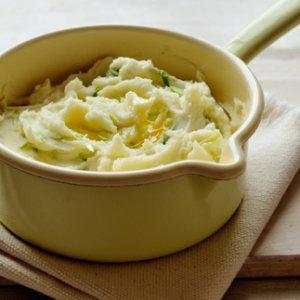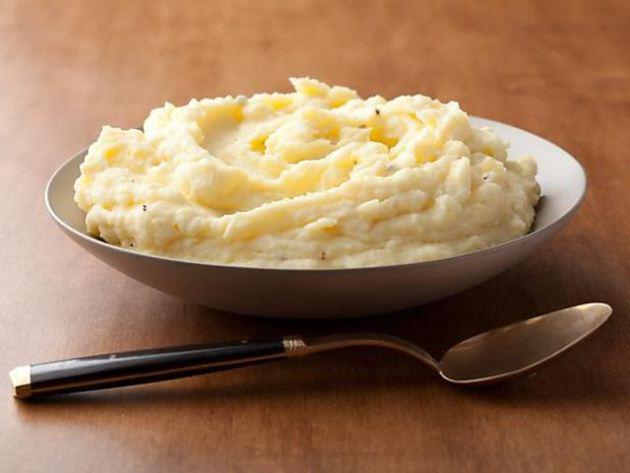The first image is the image on the left, the second image is the image on the right. Evaluate the accuracy of this statement regarding the images: "The right hand dish has slightly fluted edges.". Is it true? Answer yes or no. No. 